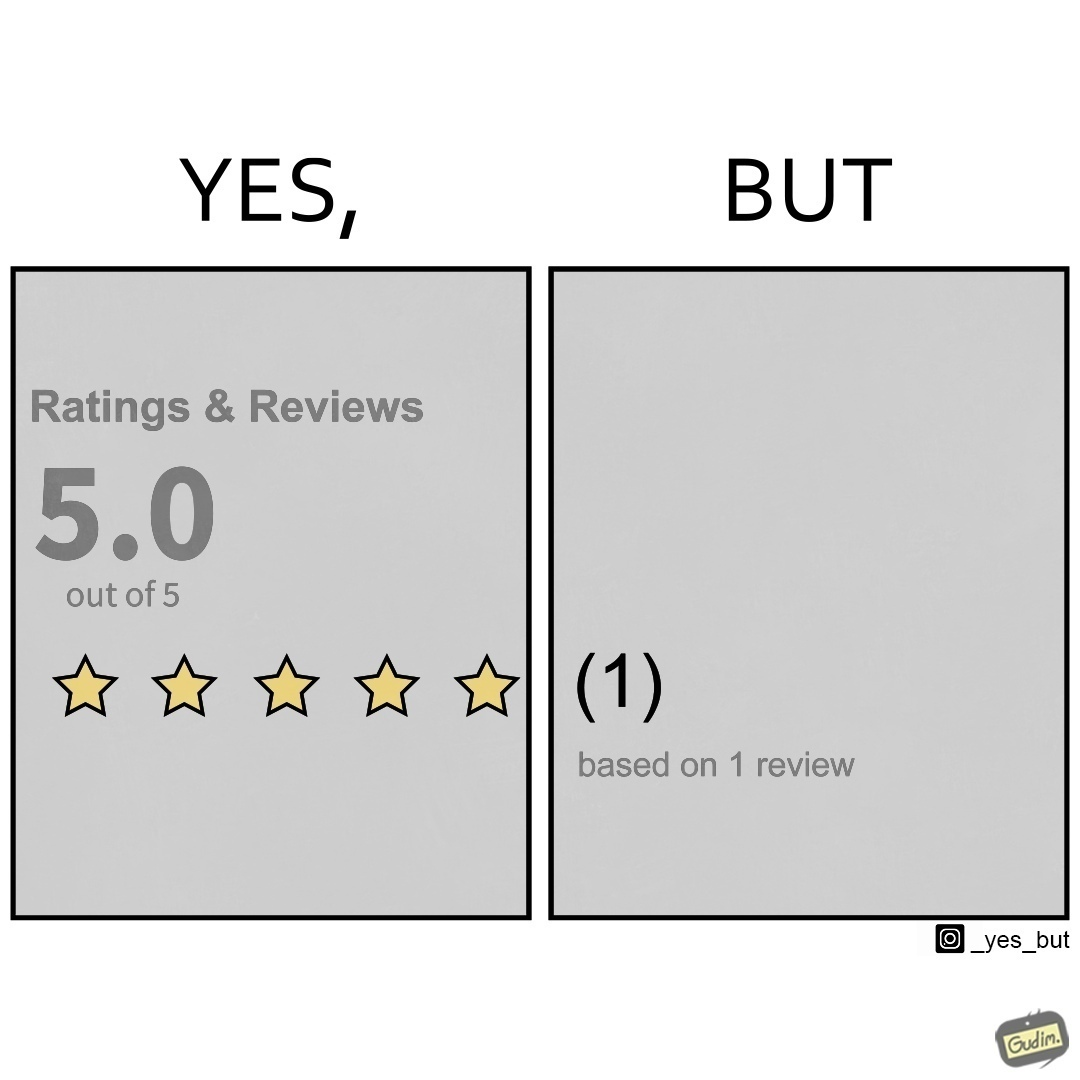Why is this image considered satirical? The image is ironical, as a product/service is rated 5 out of 5 stars, but it has only 1 review, and hence, this rating might actually be misleading. 